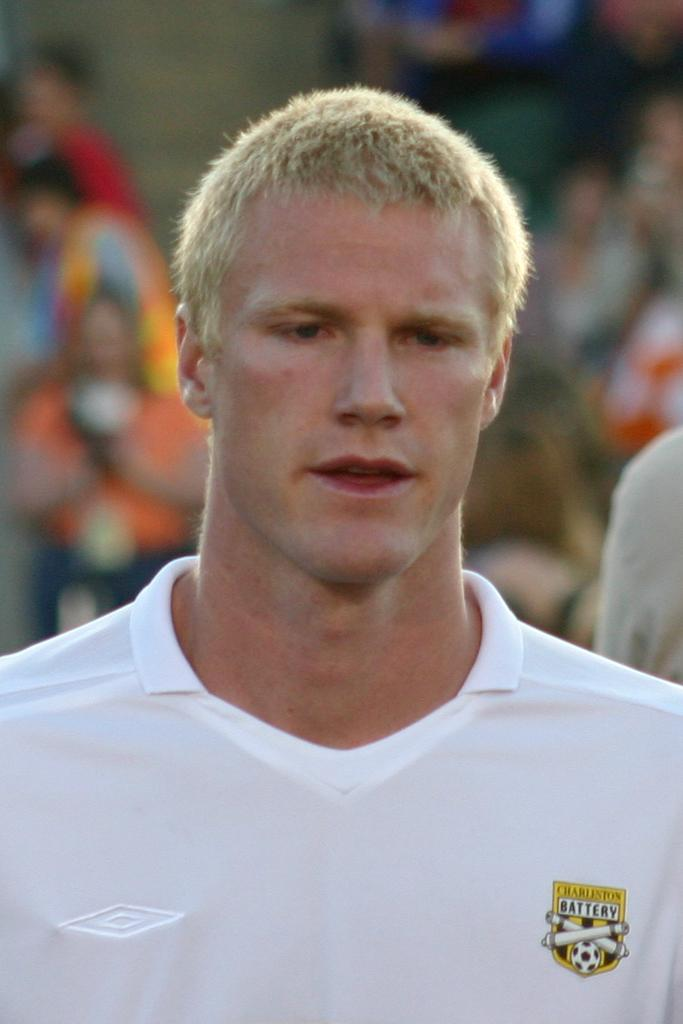What can be seen in the image? There is a person in the image. What is the person wearing? The person is wearing a white t-shirt. Can you describe the background of the image? The background of the image is blurred. Is there any blood visible on the person's white t-shirt in the image? No, there is no blood visible on the person's white t-shirt in the image. 